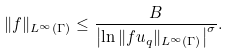<formula> <loc_0><loc_0><loc_500><loc_500>\| f \| _ { L ^ { \infty } ( \Gamma ) } \leq \frac { B } { \left | \ln \| f u _ { q } \| _ { L ^ { \infty } ( \Gamma ) } \right | ^ { \sigma } } .</formula> 